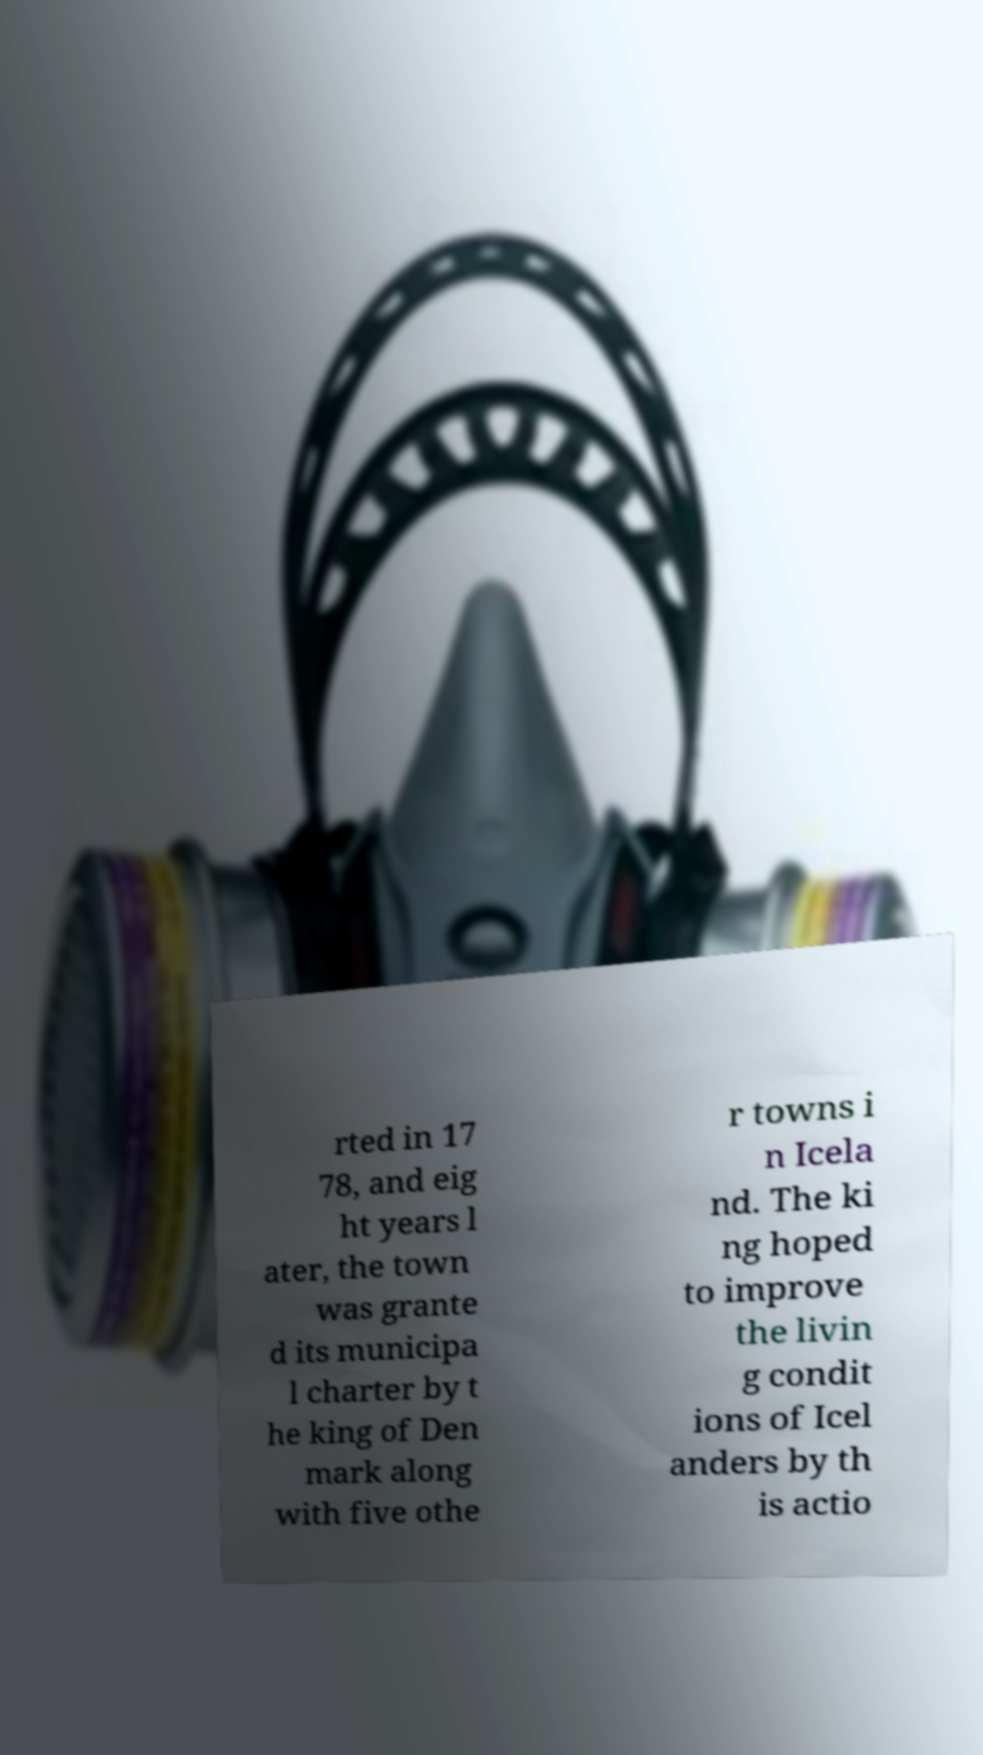Please read and relay the text visible in this image. What does it say? rted in 17 78, and eig ht years l ater, the town was grante d its municipa l charter by t he king of Den mark along with five othe r towns i n Icela nd. The ki ng hoped to improve the livin g condit ions of Icel anders by th is actio 